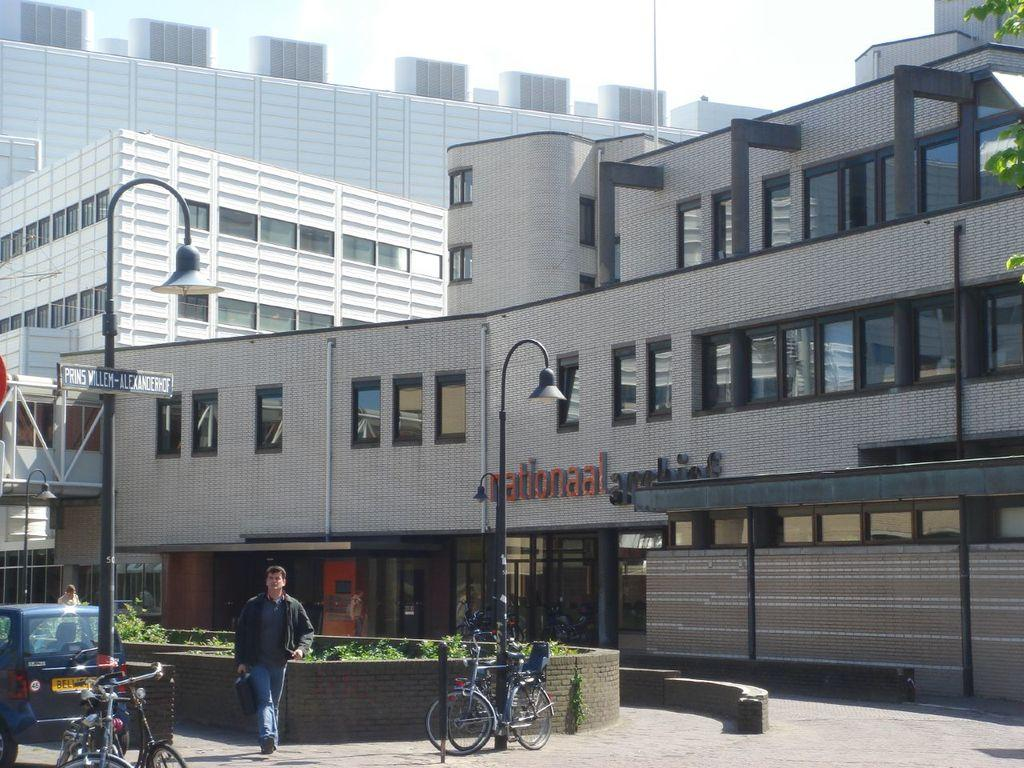What type of structures can be seen in the background of the image? There are buildings in the background of the image. What are the tall, vertical objects in the image? There are light poles in the image. What mode of transportation can be seen in the image? There are bicycles and a car in the image. What is the person in the image doing? There is a person walking on the road in the image. What type of picture is hanging on the wall in the image? There is no picture hanging on the wall in the image. Is there a prison visible in the image? No, there is no prison present in the image. 